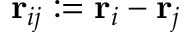Convert formula to latex. <formula><loc_0><loc_0><loc_500><loc_500>r _ { i j } \colon = r _ { i } - r _ { j }</formula> 